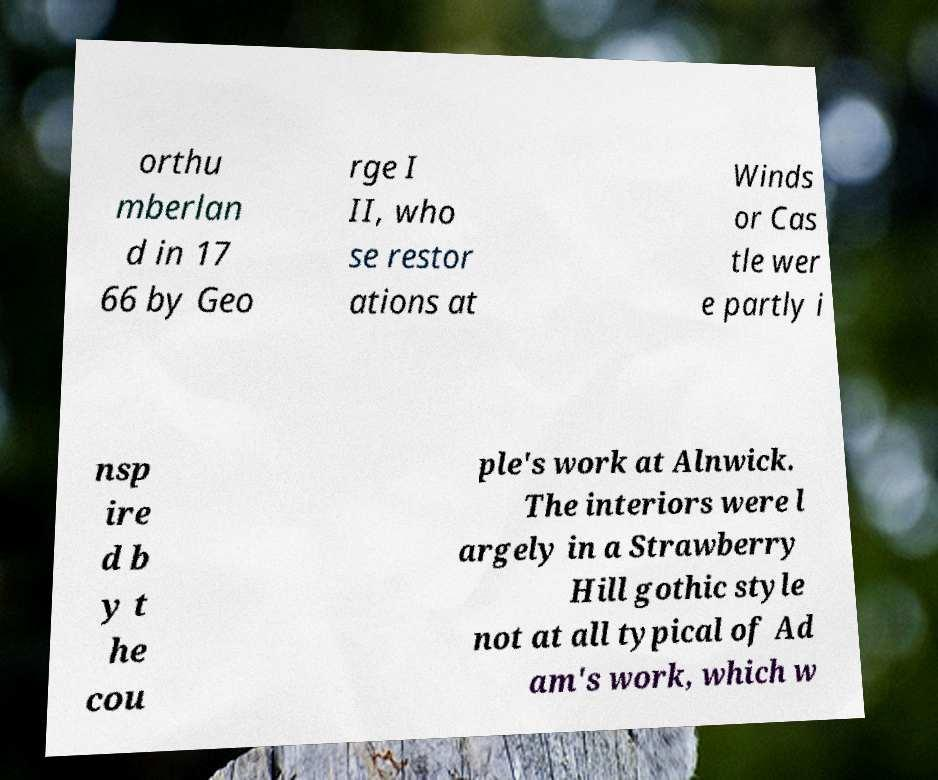Can you read and provide the text displayed in the image?This photo seems to have some interesting text. Can you extract and type it out for me? orthu mberlan d in 17 66 by Geo rge I II, who se restor ations at Winds or Cas tle wer e partly i nsp ire d b y t he cou ple's work at Alnwick. The interiors were l argely in a Strawberry Hill gothic style not at all typical of Ad am's work, which w 